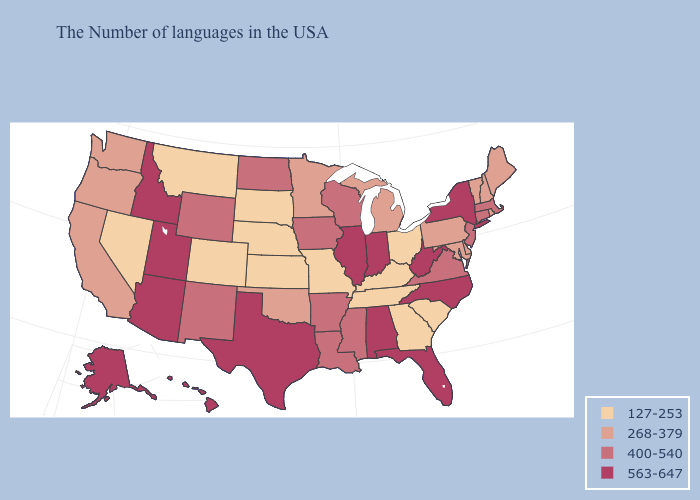Does the first symbol in the legend represent the smallest category?
Concise answer only. Yes. Does Washington have the same value as Oklahoma?
Quick response, please. Yes. Which states hav the highest value in the South?
Give a very brief answer. North Carolina, West Virginia, Florida, Alabama, Texas. Does Pennsylvania have a lower value than Oregon?
Answer briefly. No. Does Louisiana have a higher value than Virginia?
Keep it brief. No. What is the highest value in the USA?
Give a very brief answer. 563-647. Name the states that have a value in the range 400-540?
Short answer required. Massachusetts, Connecticut, New Jersey, Virginia, Wisconsin, Mississippi, Louisiana, Arkansas, Iowa, North Dakota, Wyoming, New Mexico. What is the lowest value in the West?
Answer briefly. 127-253. What is the value of Vermont?
Concise answer only. 268-379. What is the highest value in states that border Oregon?
Keep it brief. 563-647. Name the states that have a value in the range 127-253?
Give a very brief answer. South Carolina, Ohio, Georgia, Kentucky, Tennessee, Missouri, Kansas, Nebraska, South Dakota, Colorado, Montana, Nevada. What is the value of West Virginia?
Write a very short answer. 563-647. Does the map have missing data?
Write a very short answer. No. What is the lowest value in the USA?
Keep it brief. 127-253. Name the states that have a value in the range 400-540?
Short answer required. Massachusetts, Connecticut, New Jersey, Virginia, Wisconsin, Mississippi, Louisiana, Arkansas, Iowa, North Dakota, Wyoming, New Mexico. 